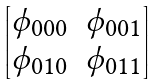Convert formula to latex. <formula><loc_0><loc_0><loc_500><loc_500>\begin{bmatrix} \phi _ { 0 0 0 } & \phi _ { 0 0 1 } \\ \phi _ { 0 1 0 } & \phi _ { 0 1 1 } \end{bmatrix}</formula> 